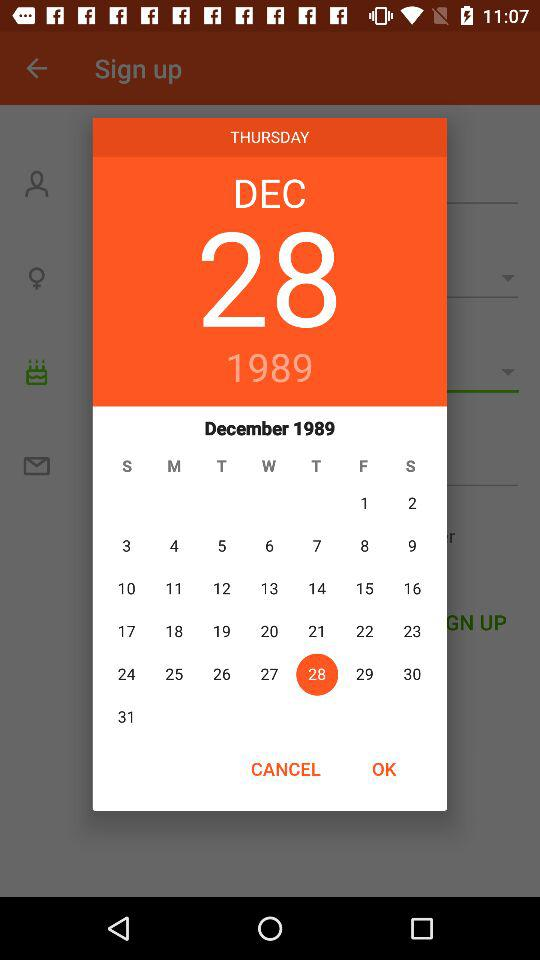What would be the day on the 28th of December, 1989? The day would be "THURSDAY". 